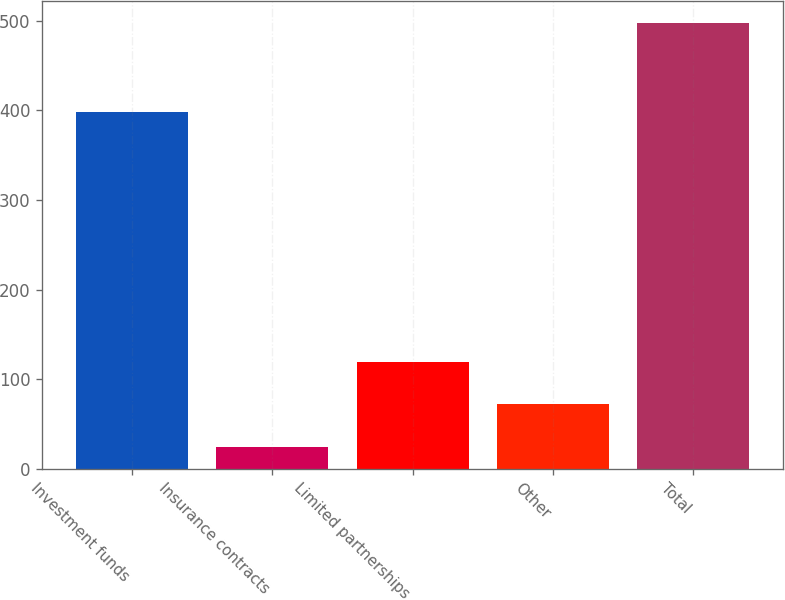Convert chart. <chart><loc_0><loc_0><loc_500><loc_500><bar_chart><fcel>Investment funds<fcel>Insurance contracts<fcel>Limited partnerships<fcel>Other<fcel>Total<nl><fcel>398.4<fcel>24.8<fcel>119.32<fcel>72.06<fcel>497.4<nl></chart> 